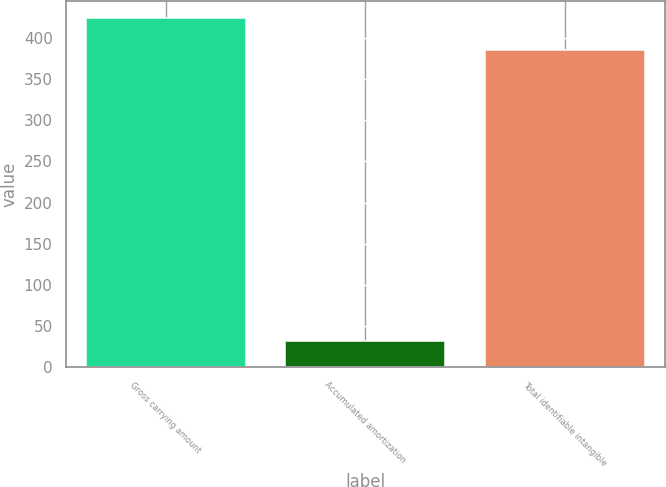Convert chart to OTSL. <chart><loc_0><loc_0><loc_500><loc_500><bar_chart><fcel>Gross carrying amount<fcel>Accumulated amortization<fcel>Total identifiable intangible<nl><fcel>423.94<fcel>31.9<fcel>385.4<nl></chart> 